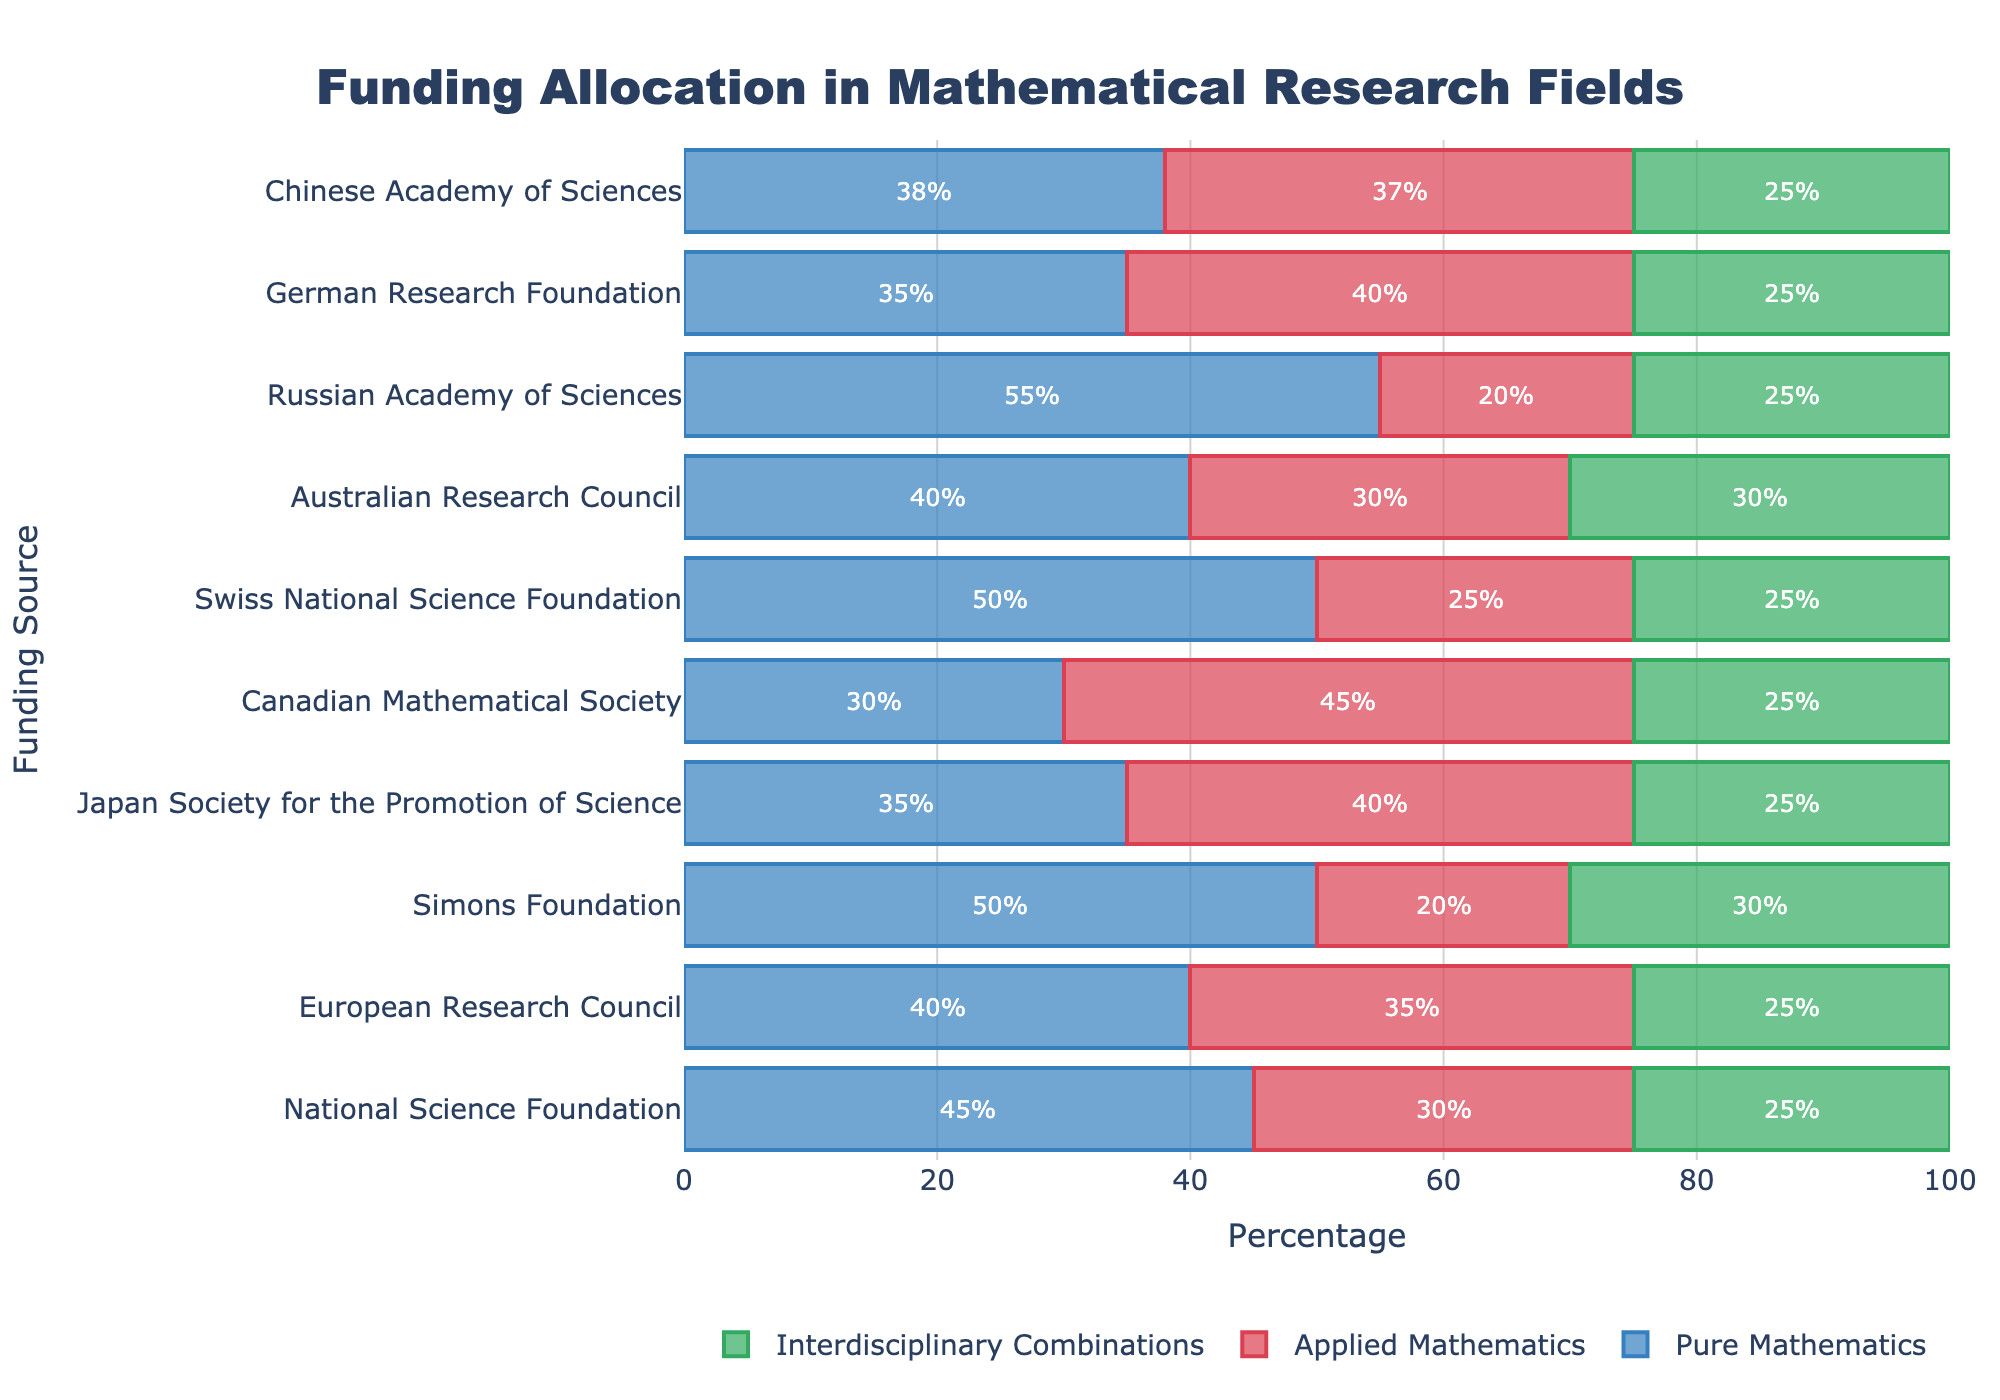Which funding source allocates the highest percentage to pure mathematics? By looking at the lengths of the blue bars representing pure mathematics, the Russian Academy of Sciences has the longest blue bar at 55%.
Answer: Russian Academy of Sciences Which funding source dedicates the largest percentage to applied mathematics? The red bars denote applied mathematics, and the Canadian Mathematical Society, with the longest red bar at 45%, has the highest allocation.
Answer: Canadian Mathematical Society Sum the percentages of pure mathematics and applied mathematics for the Simons Foundation. What is the total? The pure mathematics and applied mathematics percentages for the Simons Foundation are 50% and 20%, respectively. Adding them together, 50 + 20 = 70.
Answer: 70% Which funding source has equal percentages allocated to interdisciplinary combinations? The green bars for interdisciplinary combinations, specifically, several funding sources (e.g., National Science Foundation, European Research Council, Simons Foundation, Japan Society for the Promotion of Science, Canadian Mathematical Society, Swiss National Science Foundation, Russian Academy of Sciences, and German Research Foundation) all show 25%.
Answer: National Science Foundation, European Research Council, Simons Foundation, Japan Society for the Promotion of Science, Canadian Mathematical Society, Swiss National Science Foundation, German Research Foundation, Chinese Academy of Sciences How many funding sources allocate more than 40% to applied mathematics? By visually inspecting the red bars (applied mathematics), four sources allocate more than 40%: Japanese Society for the Promotion of Science, Canadian Mathematical Society, German Research Foundation, and Chinese Academy of Sciences.
Answer: 4 What is the difference in pure mathematics funding between the Simons Foundation and the Swiss National Science Foundation? The pure mathematics funding percentage is 50% for both the Simons Foundation and the Swiss National Science Foundation, resulting in a difference of 0.
Answer: 0% Compare the applied mathematics funding of the European Research Council and Australian Research Council. Which one allocates more, and by how much? The applied mathematics percentages for the European Research Council and Australian Research Council are 35% and 30% respectively. The difference is 35 - 30 = 5. Therefore, the European Research Council allocates more by 5%.
Answer: European Research Council, 5% Which funding source distributes funding equally across all three categories (pure mathematics, applied mathematics, and interdisciplinary combinations)? By examining the bars for equal lengths, the Australian Research Council allocates 40% to pure mathematics, 30% to applied mathematics, and 30% to interdisciplinary combinations - not equal. None have equal distribution, so none fit this criterion.
Answer: None 